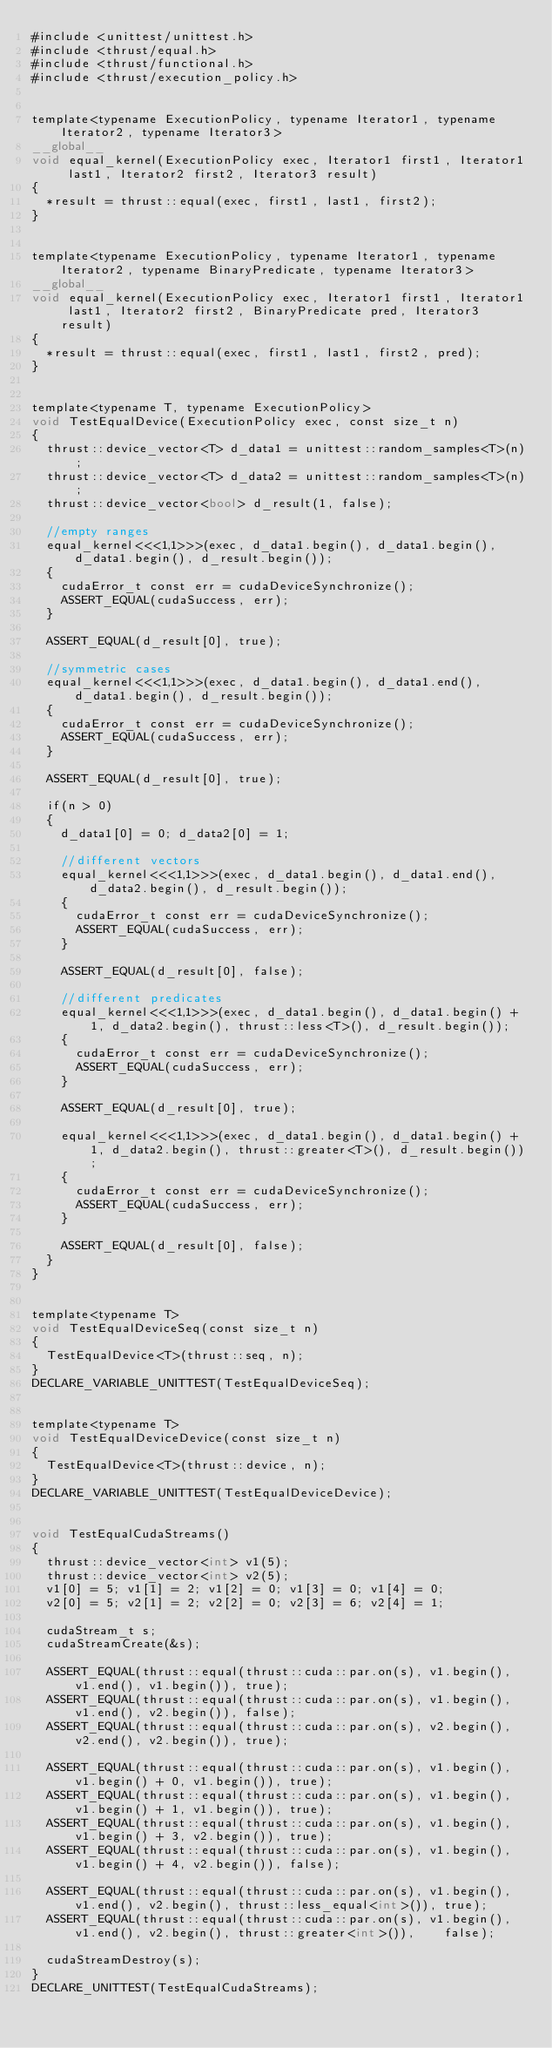<code> <loc_0><loc_0><loc_500><loc_500><_Cuda_>#include <unittest/unittest.h>
#include <thrust/equal.h>
#include <thrust/functional.h>
#include <thrust/execution_policy.h>


template<typename ExecutionPolicy, typename Iterator1, typename Iterator2, typename Iterator3>
__global__
void equal_kernel(ExecutionPolicy exec, Iterator1 first1, Iterator1 last1, Iterator2 first2, Iterator3 result)
{
  *result = thrust::equal(exec, first1, last1, first2);
}


template<typename ExecutionPolicy, typename Iterator1, typename Iterator2, typename BinaryPredicate, typename Iterator3>
__global__
void equal_kernel(ExecutionPolicy exec, Iterator1 first1, Iterator1 last1, Iterator2 first2, BinaryPredicate pred, Iterator3 result)
{
  *result = thrust::equal(exec, first1, last1, first2, pred);
}


template<typename T, typename ExecutionPolicy>
void TestEqualDevice(ExecutionPolicy exec, const size_t n)
{
  thrust::device_vector<T> d_data1 = unittest::random_samples<T>(n);
  thrust::device_vector<T> d_data2 = unittest::random_samples<T>(n);
  thrust::device_vector<bool> d_result(1, false);
  
  //empty ranges
  equal_kernel<<<1,1>>>(exec, d_data1.begin(), d_data1.begin(), d_data1.begin(), d_result.begin());
  {
    cudaError_t const err = cudaDeviceSynchronize();
    ASSERT_EQUAL(cudaSuccess, err);
  }

  ASSERT_EQUAL(d_result[0], true);
  
  //symmetric cases
  equal_kernel<<<1,1>>>(exec, d_data1.begin(), d_data1.end(), d_data1.begin(), d_result.begin());
  {
    cudaError_t const err = cudaDeviceSynchronize();
    ASSERT_EQUAL(cudaSuccess, err);
  }

  ASSERT_EQUAL(d_result[0], true);
  
  if(n > 0)
  {
    d_data1[0] = 0; d_data2[0] = 1;
    
    //different vectors
    equal_kernel<<<1,1>>>(exec, d_data1.begin(), d_data1.end(), d_data2.begin(), d_result.begin());
    {
      cudaError_t const err = cudaDeviceSynchronize();
      ASSERT_EQUAL(cudaSuccess, err);
    }

    ASSERT_EQUAL(d_result[0], false);
    
    //different predicates
    equal_kernel<<<1,1>>>(exec, d_data1.begin(), d_data1.begin() + 1, d_data2.begin(), thrust::less<T>(), d_result.begin());
    {
      cudaError_t const err = cudaDeviceSynchronize();
      ASSERT_EQUAL(cudaSuccess, err);
    }

    ASSERT_EQUAL(d_result[0], true);

    equal_kernel<<<1,1>>>(exec, d_data1.begin(), d_data1.begin() + 1, d_data2.begin(), thrust::greater<T>(), d_result.begin());
    {
      cudaError_t const err = cudaDeviceSynchronize();
      ASSERT_EQUAL(cudaSuccess, err);
    }

    ASSERT_EQUAL(d_result[0], false);
  }
}


template<typename T>
void TestEqualDeviceSeq(const size_t n)
{
  TestEqualDevice<T>(thrust::seq, n);
}
DECLARE_VARIABLE_UNITTEST(TestEqualDeviceSeq);


template<typename T>
void TestEqualDeviceDevice(const size_t n)
{
  TestEqualDevice<T>(thrust::device, n);
}
DECLARE_VARIABLE_UNITTEST(TestEqualDeviceDevice);


void TestEqualCudaStreams()
{
  thrust::device_vector<int> v1(5);
  thrust::device_vector<int> v2(5);
  v1[0] = 5; v1[1] = 2; v1[2] = 0; v1[3] = 0; v1[4] = 0;
  v2[0] = 5; v2[1] = 2; v2[2] = 0; v2[3] = 6; v2[4] = 1;

  cudaStream_t s;
  cudaStreamCreate(&s);
  
  ASSERT_EQUAL(thrust::equal(thrust::cuda::par.on(s), v1.begin(), v1.end(), v1.begin()), true);
  ASSERT_EQUAL(thrust::equal(thrust::cuda::par.on(s), v1.begin(), v1.end(), v2.begin()), false);
  ASSERT_EQUAL(thrust::equal(thrust::cuda::par.on(s), v2.begin(), v2.end(), v2.begin()), true);
  
  ASSERT_EQUAL(thrust::equal(thrust::cuda::par.on(s), v1.begin(), v1.begin() + 0, v1.begin()), true);
  ASSERT_EQUAL(thrust::equal(thrust::cuda::par.on(s), v1.begin(), v1.begin() + 1, v1.begin()), true);
  ASSERT_EQUAL(thrust::equal(thrust::cuda::par.on(s), v1.begin(), v1.begin() + 3, v2.begin()), true);
  ASSERT_EQUAL(thrust::equal(thrust::cuda::par.on(s), v1.begin(), v1.begin() + 4, v2.begin()), false);
  
  ASSERT_EQUAL(thrust::equal(thrust::cuda::par.on(s), v1.begin(), v1.end(), v2.begin(), thrust::less_equal<int>()), true);
  ASSERT_EQUAL(thrust::equal(thrust::cuda::par.on(s), v1.begin(), v1.end(), v2.begin(), thrust::greater<int>()),    false);

  cudaStreamDestroy(s);
}
DECLARE_UNITTEST(TestEqualCudaStreams);

</code> 